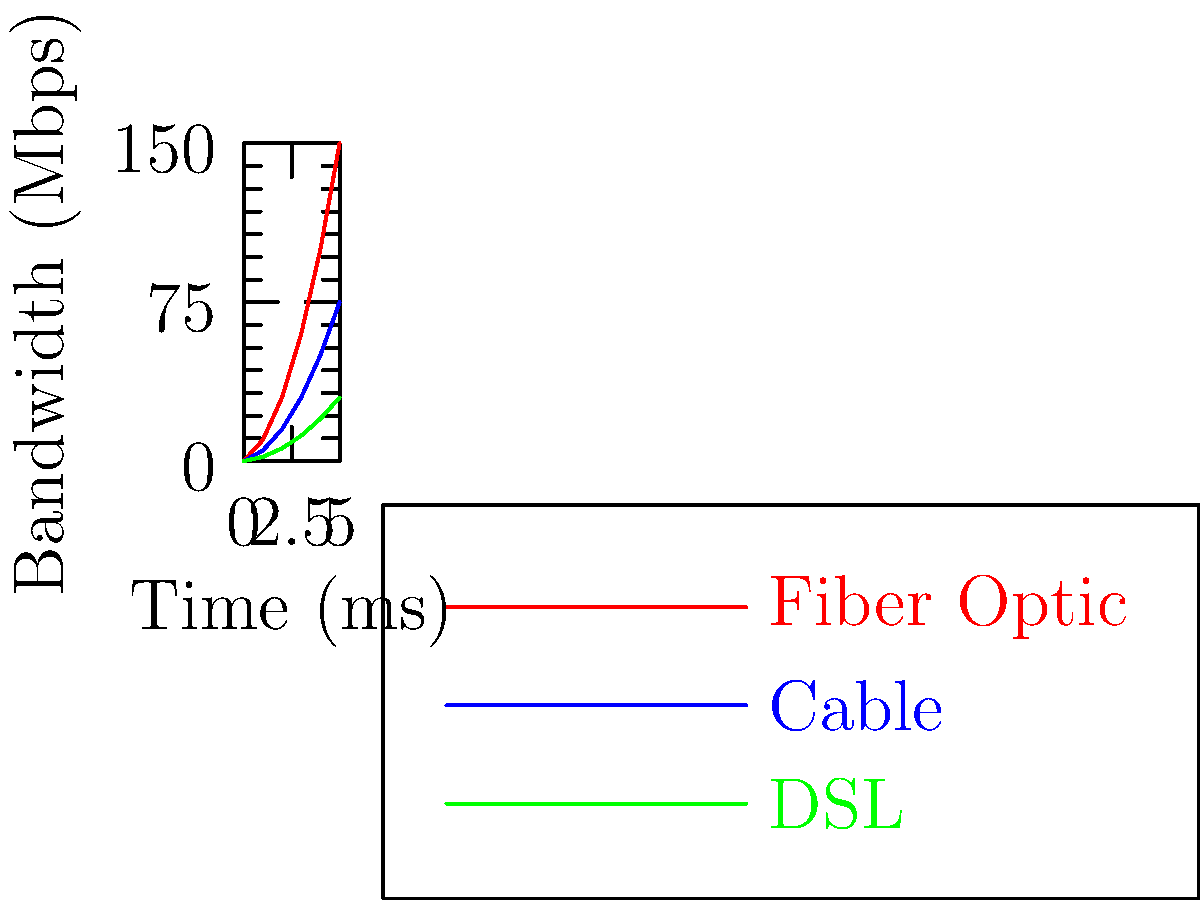As a corporate communications coordinator, you're tasked with explaining network performance to non-technical stakeholders. Based on the line graph comparing bandwidth over time for different network connections, which technology would you recommend for a company that requires high-speed data transfer but is concerned about using overly technical jargon in their communication? To answer this question, let's break down the information presented in the graph and relate it to our needs as a corporate communications coordinator:

1. The graph shows three types of network connections: Fiber Optic (red), Cable (blue), and DSL (green).

2. The x-axis represents time in milliseconds, while the y-axis shows bandwidth in Mbps (Megabits per second).

3. Analyzing the graph:
   a) Fiber Optic (red line) shows the steepest increase, reaching the highest bandwidth in the shortest time.
   b) Cable (blue line) shows a moderate increase, reaching a middle ground in terms of bandwidth.
   c) DSL (green line) shows the slowest increase and lowest overall bandwidth.

4. As a corporate communications coordinator, we need to balance technical performance with ease of communication:
   a) Fiber Optic offers the best performance but might be considered too technical for some stakeholders.
   b) DSL, while easier to explain, doesn't provide the high-speed data transfer required.
   c) Cable provides a good balance of performance and familiarity.

5. Considering the need for high-speed data transfer and the concern about using overly technical jargon, Cable would be the best recommendation.

6. Cable technology is widely known and easy to explain without resorting to specialized language, while still offering significant speed improvements over DSL.
Answer: Cable 